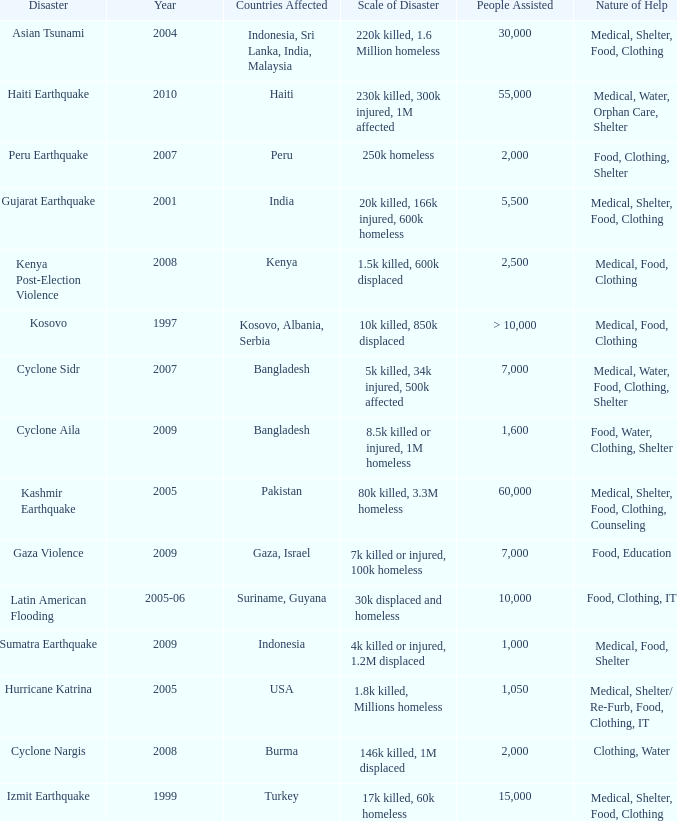What is the scale of disaster for the USA? 1.8k killed, Millions homeless. 